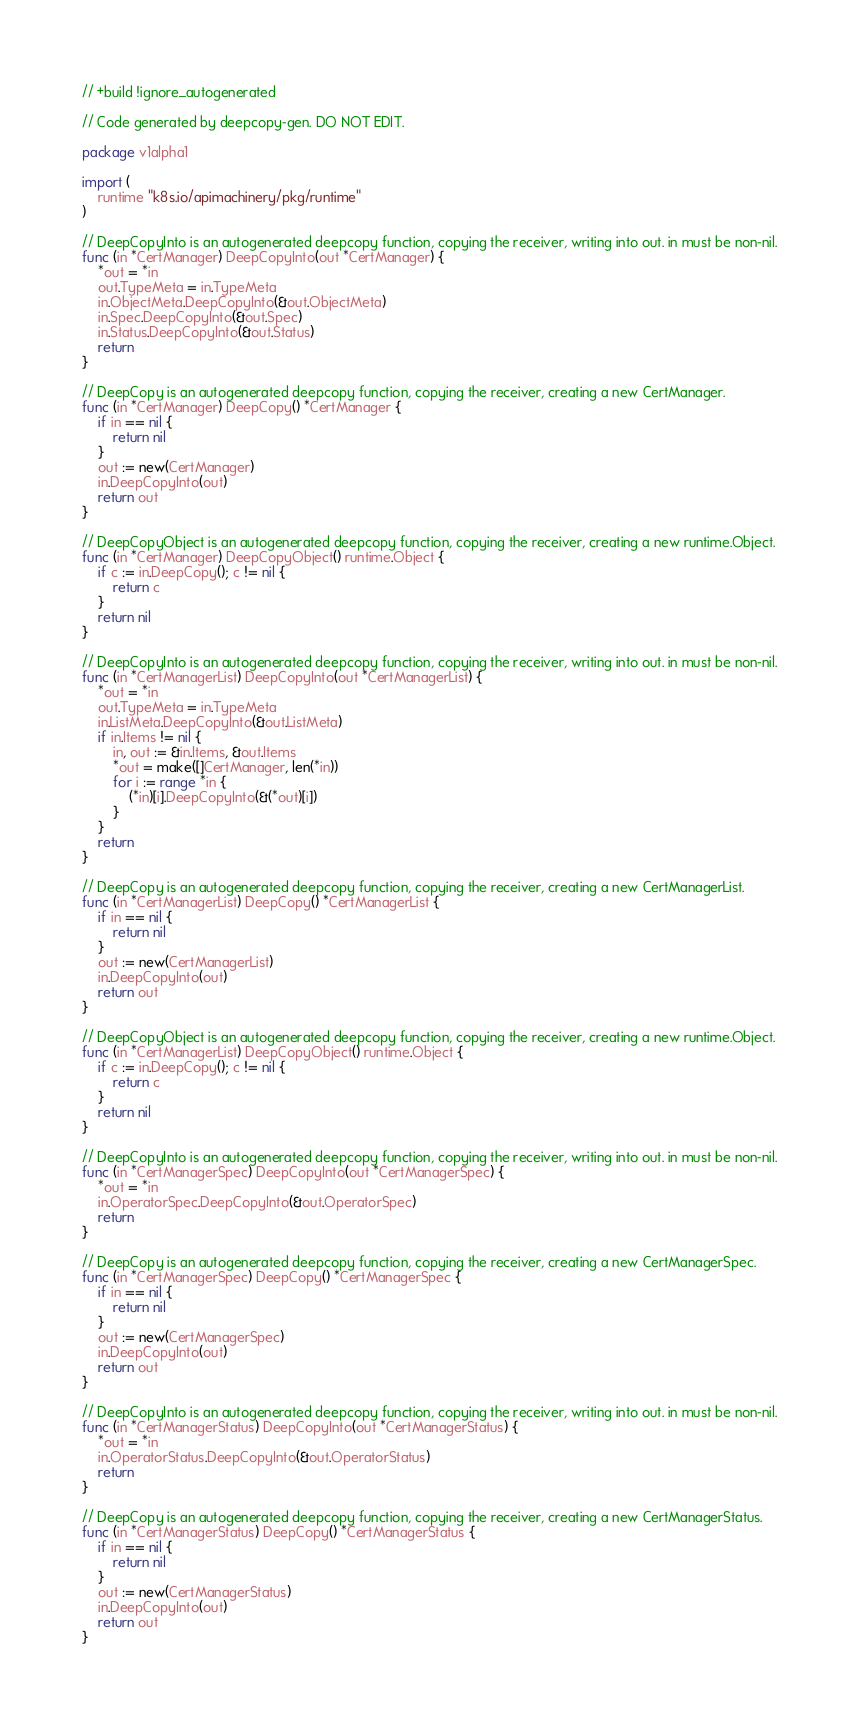<code> <loc_0><loc_0><loc_500><loc_500><_Go_>// +build !ignore_autogenerated

// Code generated by deepcopy-gen. DO NOT EDIT.

package v1alpha1

import (
	runtime "k8s.io/apimachinery/pkg/runtime"
)

// DeepCopyInto is an autogenerated deepcopy function, copying the receiver, writing into out. in must be non-nil.
func (in *CertManager) DeepCopyInto(out *CertManager) {
	*out = *in
	out.TypeMeta = in.TypeMeta
	in.ObjectMeta.DeepCopyInto(&out.ObjectMeta)
	in.Spec.DeepCopyInto(&out.Spec)
	in.Status.DeepCopyInto(&out.Status)
	return
}

// DeepCopy is an autogenerated deepcopy function, copying the receiver, creating a new CertManager.
func (in *CertManager) DeepCopy() *CertManager {
	if in == nil {
		return nil
	}
	out := new(CertManager)
	in.DeepCopyInto(out)
	return out
}

// DeepCopyObject is an autogenerated deepcopy function, copying the receiver, creating a new runtime.Object.
func (in *CertManager) DeepCopyObject() runtime.Object {
	if c := in.DeepCopy(); c != nil {
		return c
	}
	return nil
}

// DeepCopyInto is an autogenerated deepcopy function, copying the receiver, writing into out. in must be non-nil.
func (in *CertManagerList) DeepCopyInto(out *CertManagerList) {
	*out = *in
	out.TypeMeta = in.TypeMeta
	in.ListMeta.DeepCopyInto(&out.ListMeta)
	if in.Items != nil {
		in, out := &in.Items, &out.Items
		*out = make([]CertManager, len(*in))
		for i := range *in {
			(*in)[i].DeepCopyInto(&(*out)[i])
		}
	}
	return
}

// DeepCopy is an autogenerated deepcopy function, copying the receiver, creating a new CertManagerList.
func (in *CertManagerList) DeepCopy() *CertManagerList {
	if in == nil {
		return nil
	}
	out := new(CertManagerList)
	in.DeepCopyInto(out)
	return out
}

// DeepCopyObject is an autogenerated deepcopy function, copying the receiver, creating a new runtime.Object.
func (in *CertManagerList) DeepCopyObject() runtime.Object {
	if c := in.DeepCopy(); c != nil {
		return c
	}
	return nil
}

// DeepCopyInto is an autogenerated deepcopy function, copying the receiver, writing into out. in must be non-nil.
func (in *CertManagerSpec) DeepCopyInto(out *CertManagerSpec) {
	*out = *in
	in.OperatorSpec.DeepCopyInto(&out.OperatorSpec)
	return
}

// DeepCopy is an autogenerated deepcopy function, copying the receiver, creating a new CertManagerSpec.
func (in *CertManagerSpec) DeepCopy() *CertManagerSpec {
	if in == nil {
		return nil
	}
	out := new(CertManagerSpec)
	in.DeepCopyInto(out)
	return out
}

// DeepCopyInto is an autogenerated deepcopy function, copying the receiver, writing into out. in must be non-nil.
func (in *CertManagerStatus) DeepCopyInto(out *CertManagerStatus) {
	*out = *in
	in.OperatorStatus.DeepCopyInto(&out.OperatorStatus)
	return
}

// DeepCopy is an autogenerated deepcopy function, copying the receiver, creating a new CertManagerStatus.
func (in *CertManagerStatus) DeepCopy() *CertManagerStatus {
	if in == nil {
		return nil
	}
	out := new(CertManagerStatus)
	in.DeepCopyInto(out)
	return out
}
</code> 